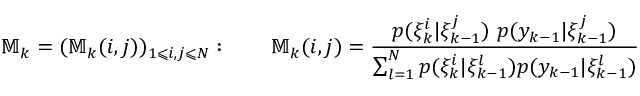Convert formula to latex. <formula><loc_0><loc_0><loc_500><loc_500>\mathbb { M } _ { k } = ( \mathbb { M } _ { k } ( i , j ) ) _ { 1 \leqslant i , j \leqslant N } \colon \quad \mathbb { M } _ { k } ( i , j ) = { \frac { p ( \xi _ { k } ^ { i } | \xi _ { k - 1 } ^ { j } ) p ( y _ { k - 1 } | \xi _ { k - 1 } ^ { j } ) } { \sum _ { l = 1 } ^ { N } p ( \xi _ { k } ^ { i } | \xi _ { k - 1 } ^ { l } ) p ( y _ { k - 1 } | \xi _ { k - 1 } ^ { l } ) } }</formula> 